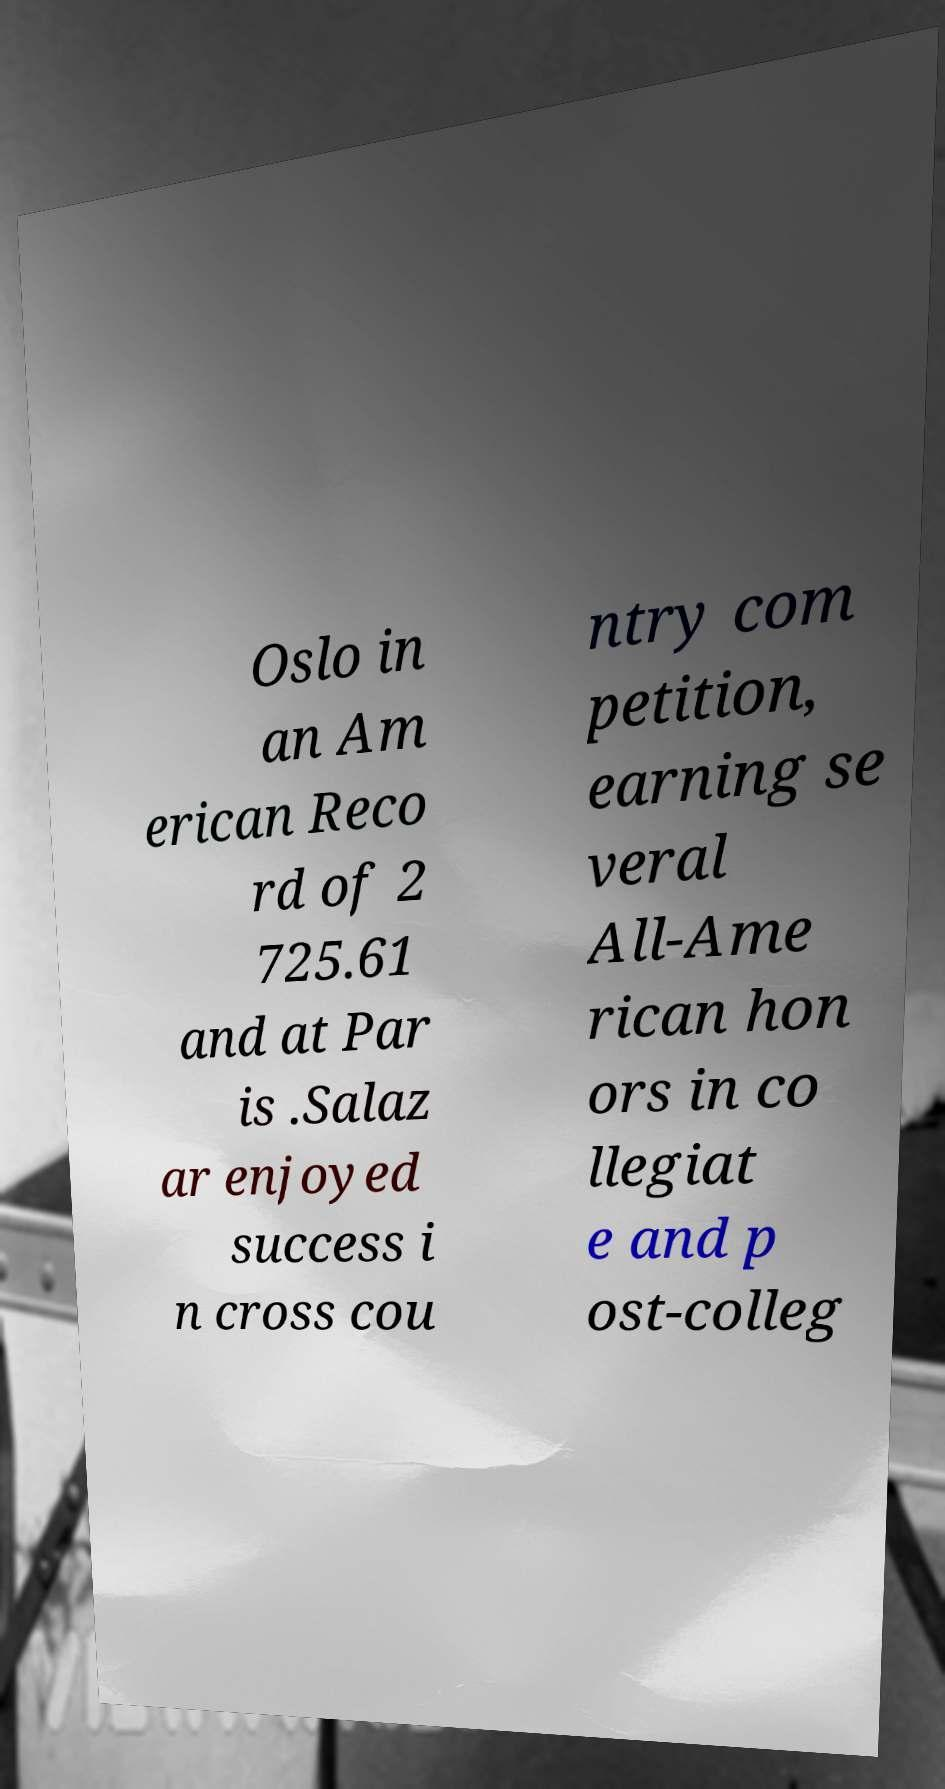There's text embedded in this image that I need extracted. Can you transcribe it verbatim? Oslo in an Am erican Reco rd of 2 725.61 and at Par is .Salaz ar enjoyed success i n cross cou ntry com petition, earning se veral All-Ame rican hon ors in co llegiat e and p ost-colleg 